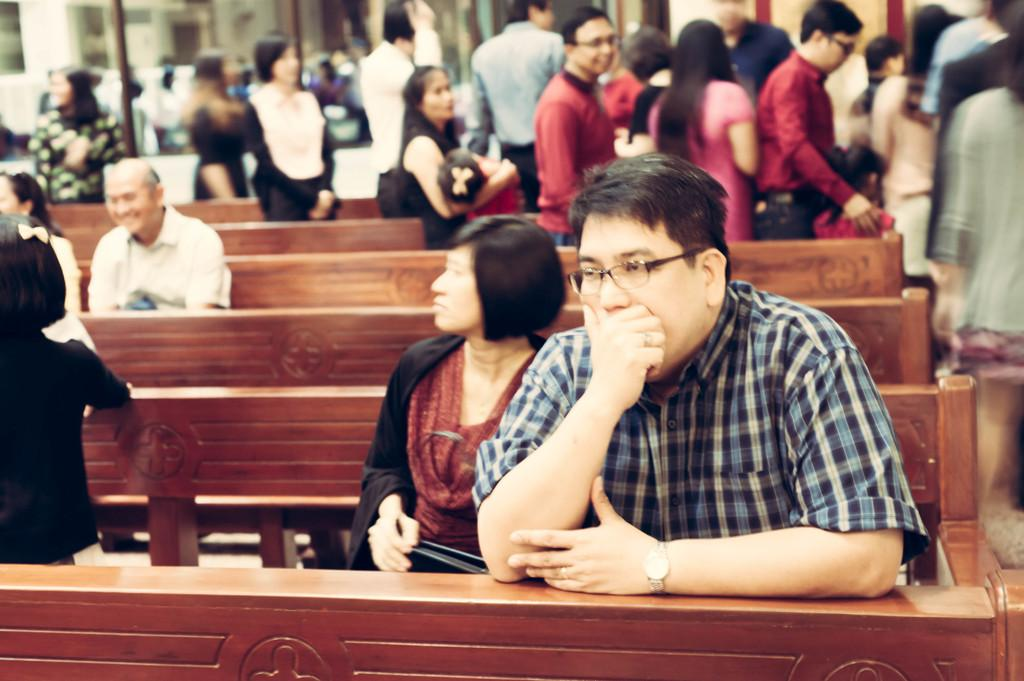What are the people in the image doing? There are people standing and sitting on benches in the image. Can you describe the positions of the people in the image? Some people are standing, while others are sitting on benches. What type of truck can be seen in the image? There is no truck present in the image; it only features people standing and sitting on benches. What song is being sung by the people in the image? There is no indication of any singing or song in the image; it only shows people standing and sitting on benches. 